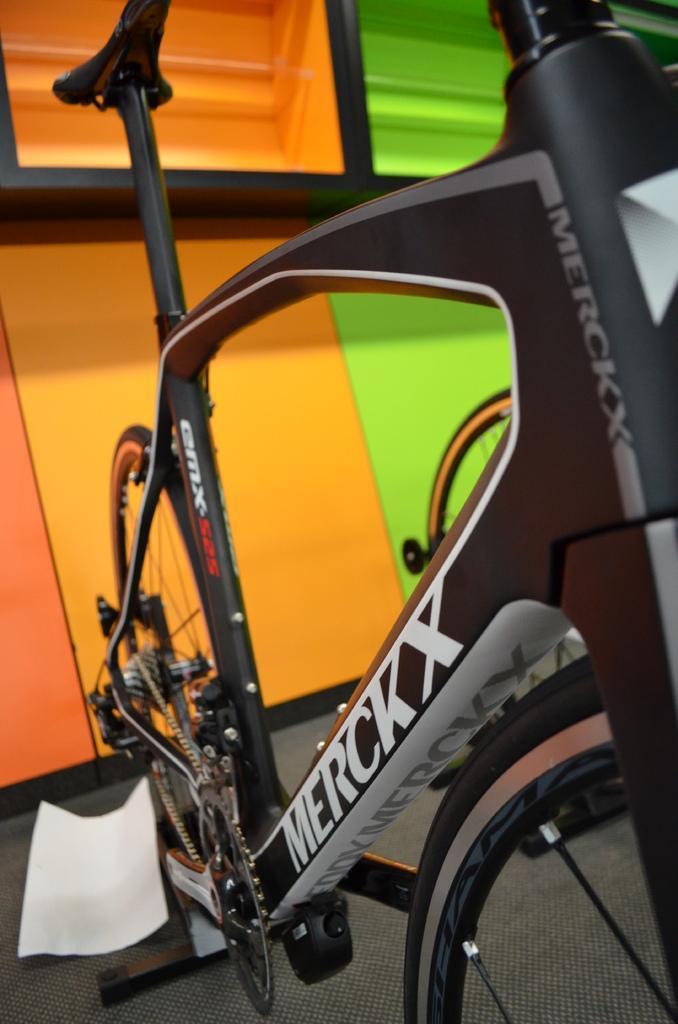Please provide a concise description of this image. In this image I can see a bicycle in black color. Background I can see a wall in orange and green color. 